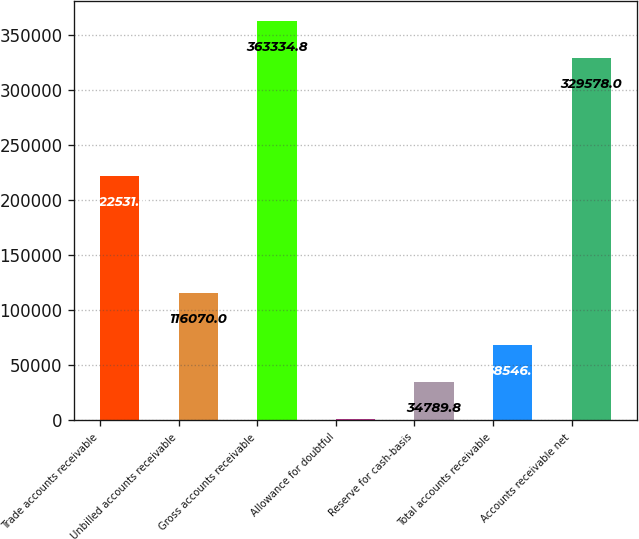Convert chart to OTSL. <chart><loc_0><loc_0><loc_500><loc_500><bar_chart><fcel>Trade accounts receivable<fcel>Unbilled accounts receivable<fcel>Gross accounts receivable<fcel>Allowance for doubtful<fcel>Reserve for cash-basis<fcel>Total accounts receivable<fcel>Accounts receivable net<nl><fcel>222531<fcel>116070<fcel>363335<fcel>1033<fcel>34789.8<fcel>68546.6<fcel>329578<nl></chart> 